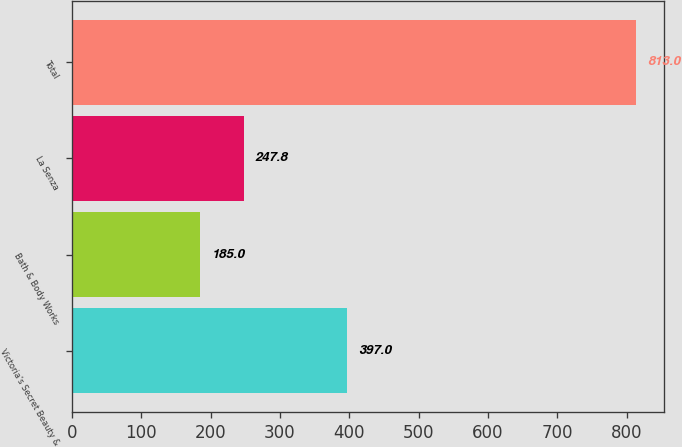<chart> <loc_0><loc_0><loc_500><loc_500><bar_chart><fcel>Victoria's Secret Beauty &<fcel>Bath & Body Works<fcel>La Senza<fcel>Total<nl><fcel>397<fcel>185<fcel>247.8<fcel>813<nl></chart> 